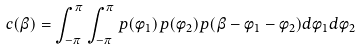<formula> <loc_0><loc_0><loc_500><loc_500>c ( \beta ) = \int ^ { \pi } _ { - \pi } { \int ^ { \pi } _ { - \pi } { p ( \phi _ { 1 } ) p ( \phi _ { 2 } ) p ( \beta - \phi _ { 1 } - \phi _ { 2 } ) d \phi _ { 1 } d \phi _ { 2 } } }</formula> 